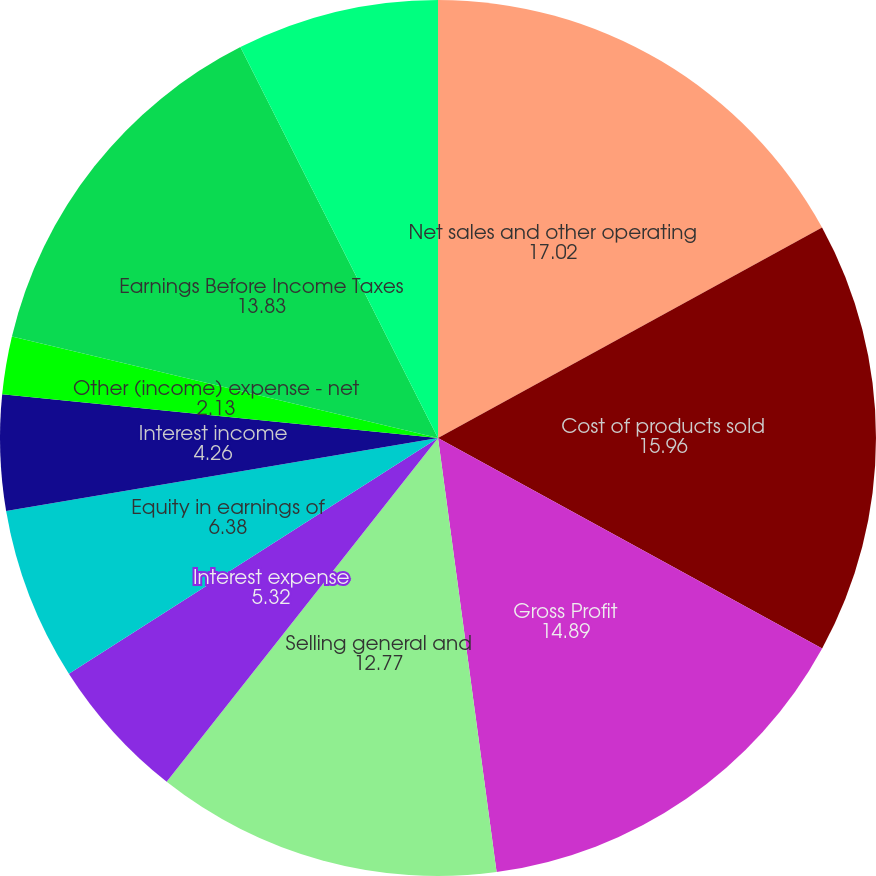<chart> <loc_0><loc_0><loc_500><loc_500><pie_chart><fcel>Net sales and other operating<fcel>Cost of products sold<fcel>Gross Profit<fcel>Selling general and<fcel>Interest expense<fcel>Equity in earnings of<fcel>Interest income<fcel>Other (income) expense - net<fcel>Earnings Before Income Taxes<fcel>Income taxes<nl><fcel>17.02%<fcel>15.96%<fcel>14.89%<fcel>12.77%<fcel>5.32%<fcel>6.38%<fcel>4.26%<fcel>2.13%<fcel>13.83%<fcel>7.45%<nl></chart> 